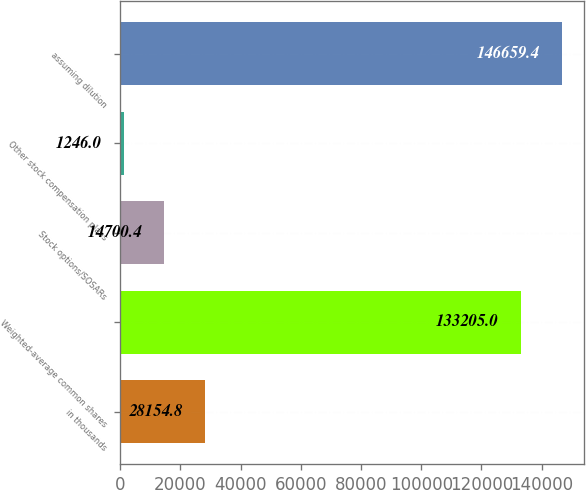Convert chart to OTSL. <chart><loc_0><loc_0><loc_500><loc_500><bar_chart><fcel>in thousands<fcel>Weighted-average common shares<fcel>Stock options/SOSARs<fcel>Other stock compensation plans<fcel>assuming dilution<nl><fcel>28154.8<fcel>133205<fcel>14700.4<fcel>1246<fcel>146659<nl></chart> 